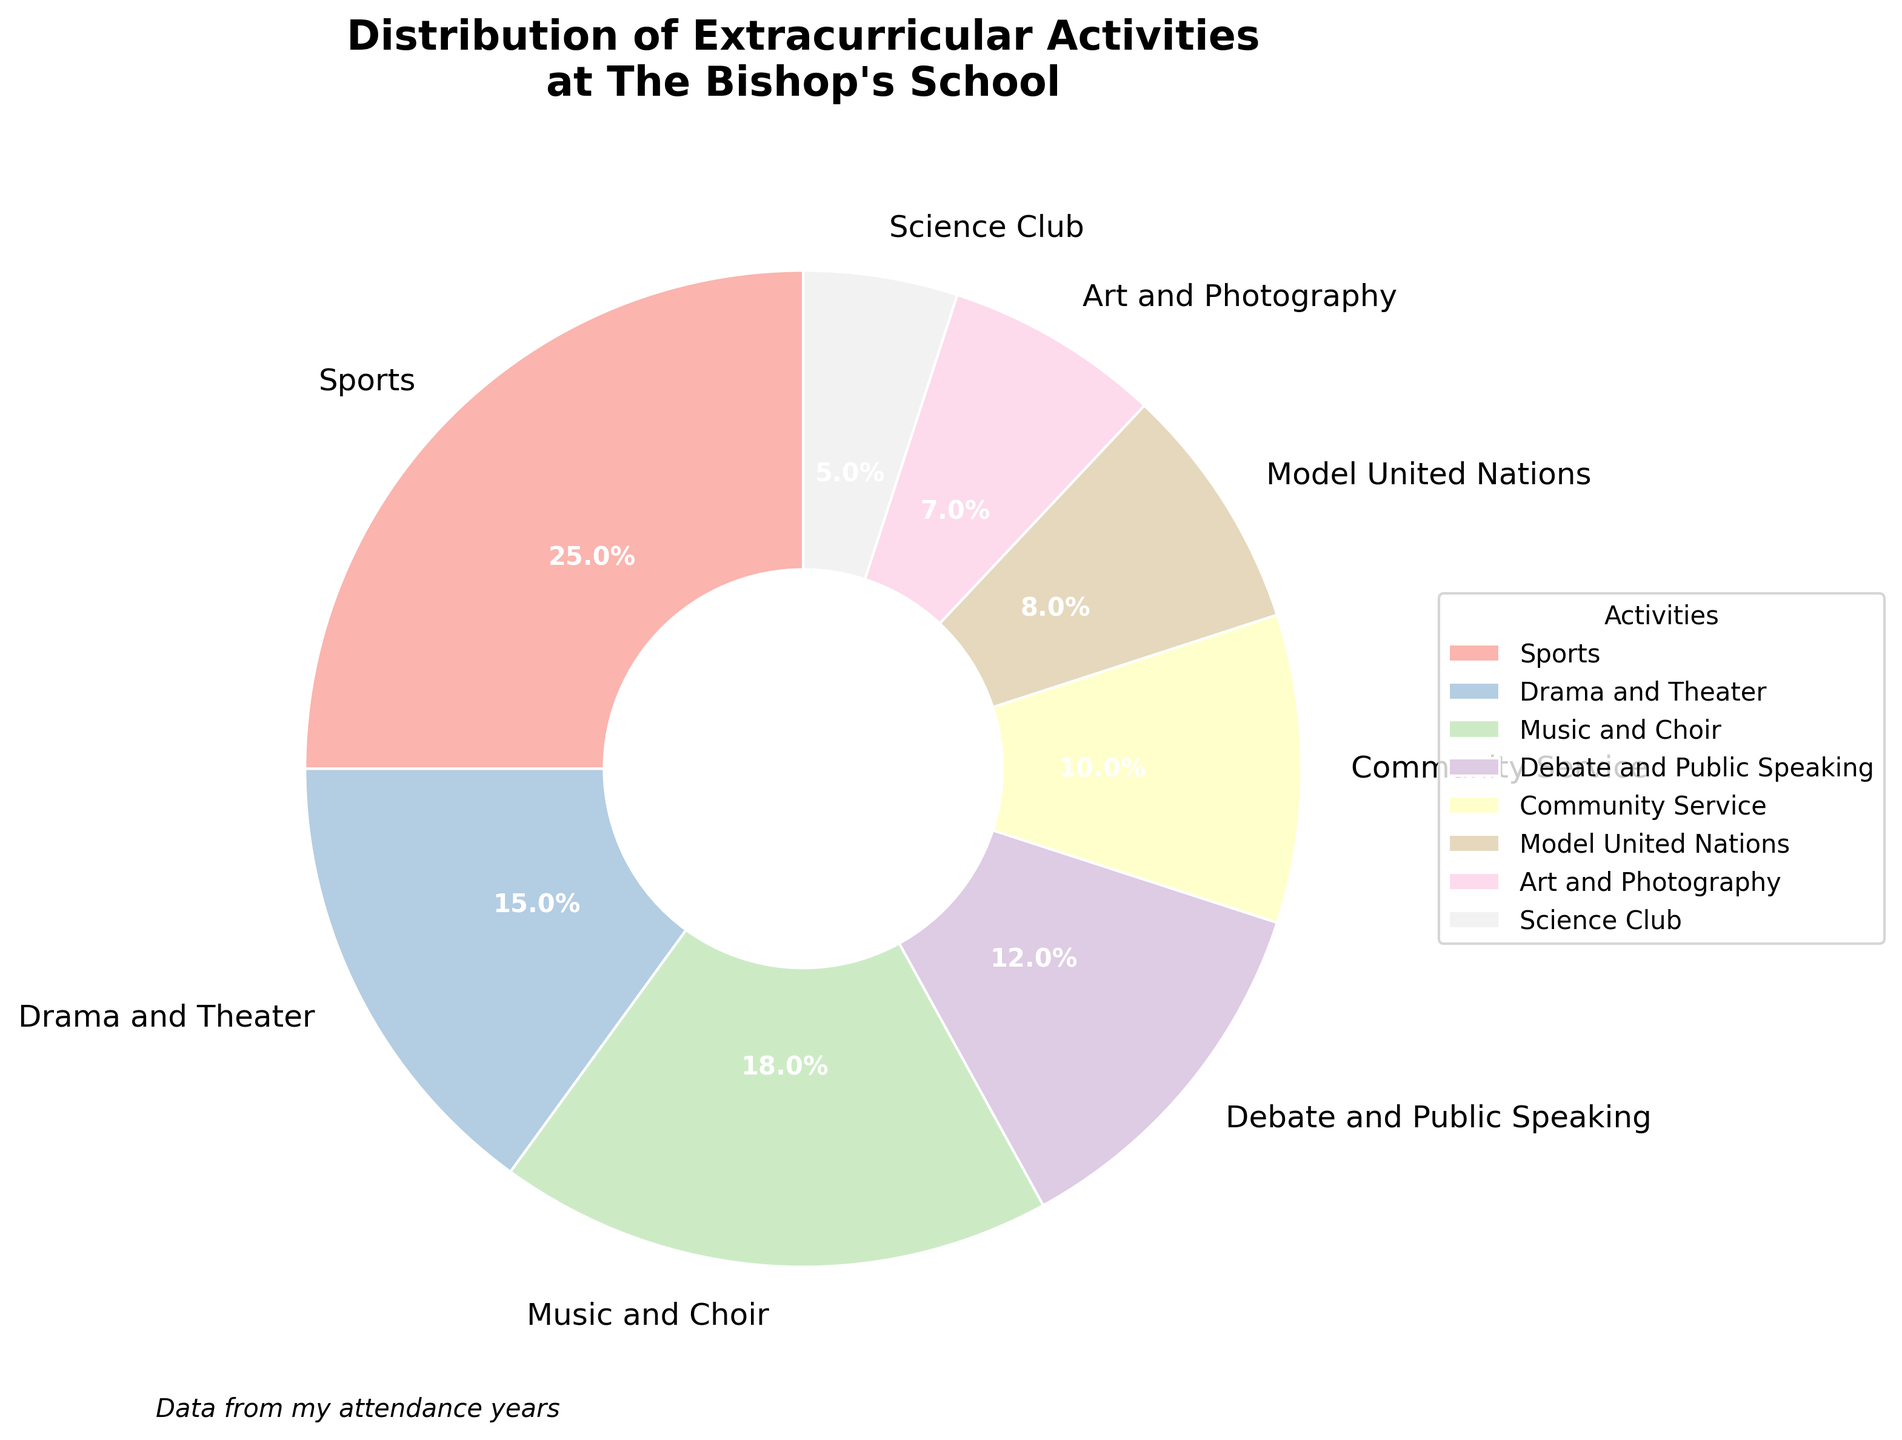What's the largest extracurricular activity group in the distribution? The largest section of the pie chart represents Sports, which has a percentage of 25%. It is visually the largest wedge in the chart.
Answer: Sports Which two activities have the closest percentages? Drama and Theater (15%) and Music and Choir (18%) are the two activities with the closest percentages in the chart, as the difference between them is only 3%.
Answer: Drama and Theater and Music and Choir How much more popular is Sports compared to Art and Photography? Sports has a percentage of 25%, while Art and Photography has 7%. The difference is 25% - 7% = 18%.
Answer: 18% Which activity percentages combine to make up more than half of the total distribution? Sports (25%), Drama and Theater (15%), and Music and Choir (18%) together make up 25% + 15% + 18% = 58%.
Answer: Sports, Drama and Theater, and Music and Choir What is the percentage difference between the most and least popular activities? The most popular activity is Sports at 25%, and the least popular is Science Club at 5%. The difference is 25% - 5% = 20%.
Answer: 20% Which activity has a wedge of a pastel color that looks the most prominent in the chart? The largest wedge with a prominent pastel color corresponds to Sports, which is visually the most prominent due to its size.
Answer: Sports Is the percentage of Debate and Public Speaking combined with Community Service greater than that of Music and Choir? Debate and Public Speaking (12%) combined with Community Service (10%) equals 12% + 10% = 22%, which is greater than Music and Choir's 18%.
Answer: Yes Compare the visual sizes of the wedges for Science Club and Model United Nations. Which is bigger? The wedge for Model United Nations (8%) is visually larger than that for Science Club (5%).
Answer: Model United Nations 